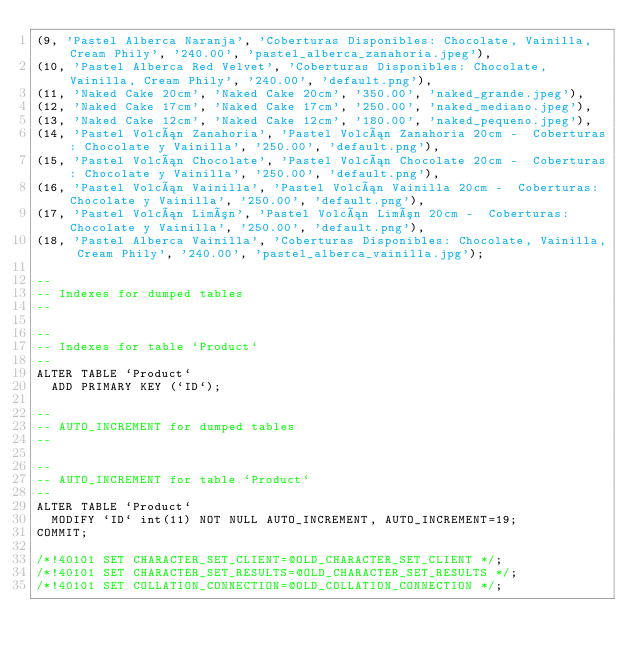Convert code to text. <code><loc_0><loc_0><loc_500><loc_500><_SQL_>(9, 'Pastel Alberca Naranja', 'Coberturas Disponibles: Chocolate, Vainilla, Cream Phily', '240.00', 'pastel_alberca_zanahoria.jpeg'),
(10, 'Pastel Alberca Red Velvet', 'Coberturas Disponibles: Chocolate, Vainilla, Cream Phily', '240.00', 'default.png'),
(11, 'Naked Cake 20cm', 'Naked Cake 20cm', '350.00', 'naked_grande.jpeg'),
(12, 'Naked Cake 17cm', 'Naked Cake 17cm', '250.00', 'naked_mediano.jpeg'),
(13, 'Naked Cake 12cm', 'Naked Cake 12cm', '180.00', 'naked_pequeno.jpeg'),
(14, 'Pastel Volcán Zanahoria', 'Pastel Volcán Zanahoria 20cm -  Coberturas: Chocolate y Vainilla', '250.00', 'default.png'),
(15, 'Pastel Volcán Chocolate', 'Pastel Volcán Chocolate 20cm -  Coberturas: Chocolate y Vainilla', '250.00', 'default.png'),
(16, 'Pastel Volcán Vainilla', 'Pastel Volcán Vainilla 20cm -  Coberturas: Chocolate y Vainilla', '250.00', 'default.png'),
(17, 'Pastel Volcán Limón', 'Pastel Volcán Limón 20cm -  Coberturas: Chocolate y Vainilla', '250.00', 'default.png'),
(18, 'Pastel Alberca Vainilla', 'Coberturas Disponibles: Chocolate, Vainilla, Cream Phily', '240.00', 'pastel_alberca_vainilla.jpg');

--
-- Indexes for dumped tables
--

--
-- Indexes for table `Product`
--
ALTER TABLE `Product`
  ADD PRIMARY KEY (`ID`);

--
-- AUTO_INCREMENT for dumped tables
--

--
-- AUTO_INCREMENT for table `Product`
--
ALTER TABLE `Product`
  MODIFY `ID` int(11) NOT NULL AUTO_INCREMENT, AUTO_INCREMENT=19;
COMMIT;

/*!40101 SET CHARACTER_SET_CLIENT=@OLD_CHARACTER_SET_CLIENT */;
/*!40101 SET CHARACTER_SET_RESULTS=@OLD_CHARACTER_SET_RESULTS */;
/*!40101 SET COLLATION_CONNECTION=@OLD_COLLATION_CONNECTION */;
</code> 